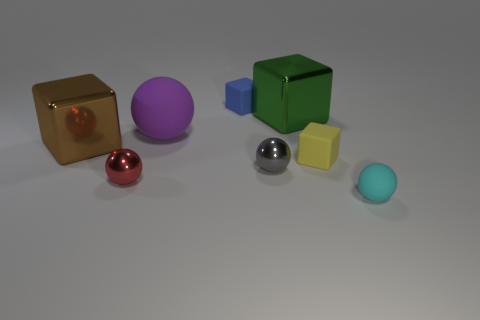The small ball that is made of the same material as the gray object is what color?
Ensure brevity in your answer.  Red. Is the number of red things in front of the big green block the same as the number of tiny cyan things that are on the left side of the big brown metallic block?
Your answer should be very brief. No. The small metal thing that is left of the tiny rubber block behind the yellow matte object is what shape?
Your response must be concise. Sphere. There is a green thing that is the same shape as the small yellow thing; what is its material?
Provide a short and direct response. Metal. There is another shiny thing that is the same size as the green thing; what color is it?
Your response must be concise. Brown. Are there an equal number of big objects that are in front of the gray ball and cyan matte spheres?
Provide a short and direct response. No. What color is the big metallic object that is on the right side of the cube that is left of the large rubber sphere?
Keep it short and to the point. Green. There is a metallic block that is left of the matte sphere that is left of the tiny rubber ball; what size is it?
Provide a succinct answer. Large. What number of other things are there of the same size as the gray sphere?
Your answer should be very brief. 4. There is a matte thing that is left of the matte block that is behind the large metal block that is behind the purple rubber thing; what color is it?
Give a very brief answer. Purple. 